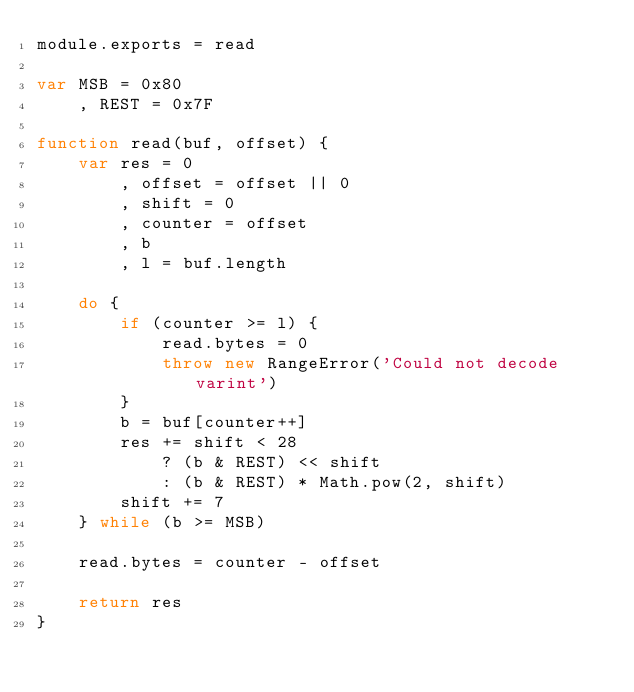<code> <loc_0><loc_0><loc_500><loc_500><_JavaScript_>module.exports = read

var MSB = 0x80
    , REST = 0x7F

function read(buf, offset) {
    var res = 0
        , offset = offset || 0
        , shift = 0
        , counter = offset
        , b
        , l = buf.length

    do {
        if (counter >= l) {
            read.bytes = 0
            throw new RangeError('Could not decode varint')
        }
        b = buf[counter++]
        res += shift < 28
            ? (b & REST) << shift
            : (b & REST) * Math.pow(2, shift)
        shift += 7
    } while (b >= MSB)

    read.bytes = counter - offset

    return res
}
</code> 